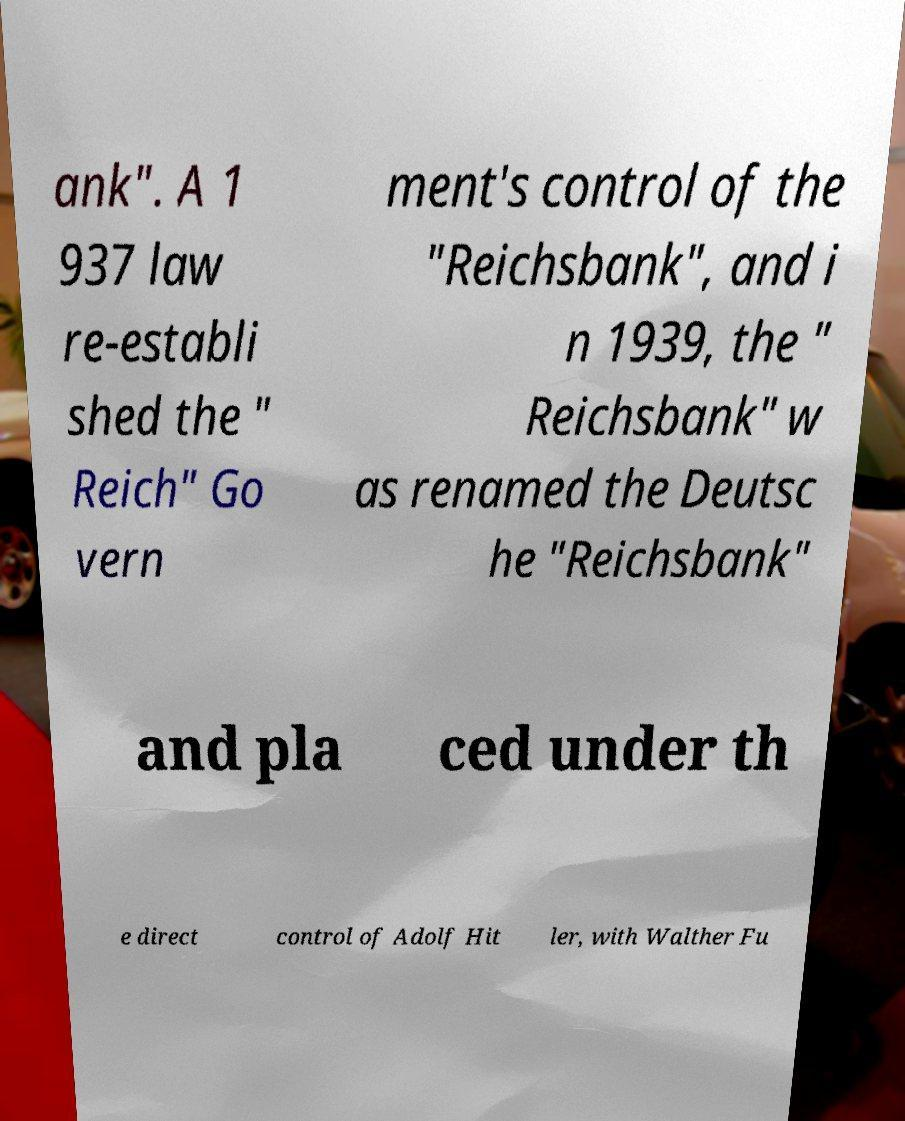Could you extract and type out the text from this image? ank". A 1 937 law re-establi shed the " Reich" Go vern ment's control of the "Reichsbank", and i n 1939, the " Reichsbank" w as renamed the Deutsc he "Reichsbank" and pla ced under th e direct control of Adolf Hit ler, with Walther Fu 